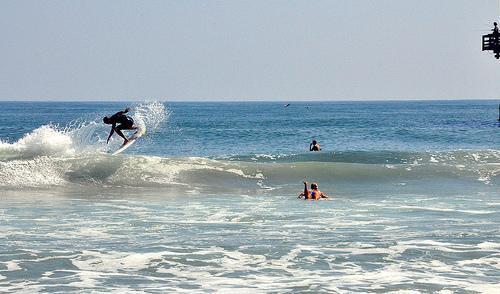How many people are in the water?
Give a very brief answer. 3. How many people are fishing?
Give a very brief answer. 1. 